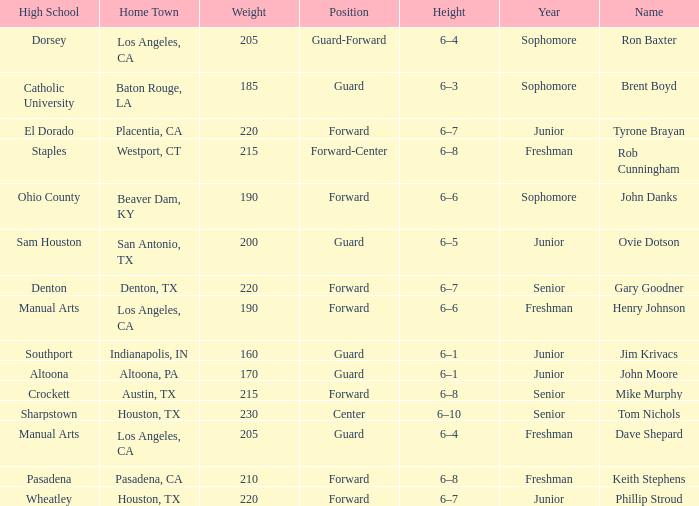What is the Name with a Year of junior, and a High School with wheatley? Phillip Stroud. 